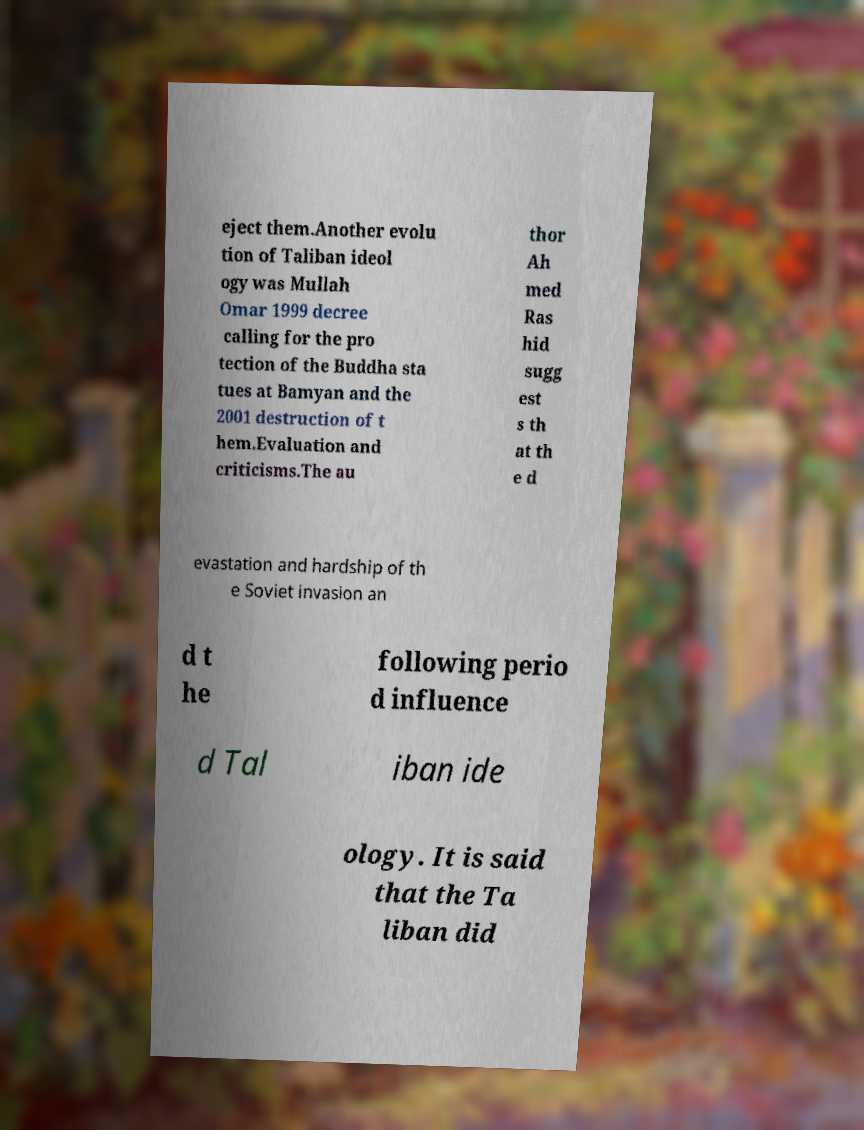For documentation purposes, I need the text within this image transcribed. Could you provide that? eject them.Another evolu tion of Taliban ideol ogy was Mullah Omar 1999 decree calling for the pro tection of the Buddha sta tues at Bamyan and the 2001 destruction of t hem.Evaluation and criticisms.The au thor Ah med Ras hid sugg est s th at th e d evastation and hardship of th e Soviet invasion an d t he following perio d influence d Tal iban ide ology. It is said that the Ta liban did 